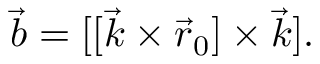<formula> <loc_0><loc_0><loc_500><loc_500>\begin{array} { r } { { \vec { b } } = [ [ { \vec { k } } \times { \vec { r } } _ { 0 } ] \times { \vec { k } } ] . } \end{array}</formula> 